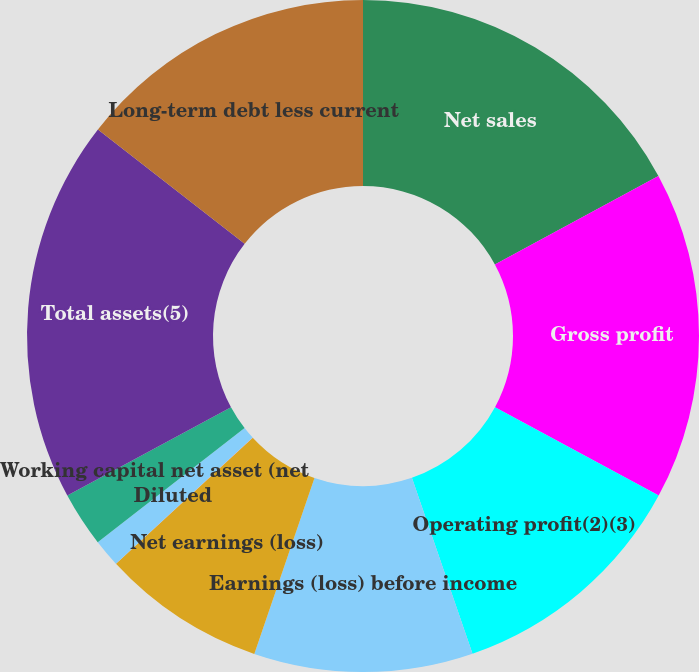<chart> <loc_0><loc_0><loc_500><loc_500><pie_chart><fcel>Net sales<fcel>Gross profit<fcel>Operating profit(2)(3)<fcel>Earnings (loss) before income<fcel>Net earnings (loss)<fcel>Basic<fcel>Diluted<fcel>Working capital net asset (net<fcel>Total assets(5)<fcel>Long-term debt less current<nl><fcel>17.1%<fcel>15.78%<fcel>11.84%<fcel>10.53%<fcel>7.9%<fcel>0.01%<fcel>1.33%<fcel>2.64%<fcel>18.41%<fcel>14.47%<nl></chart> 